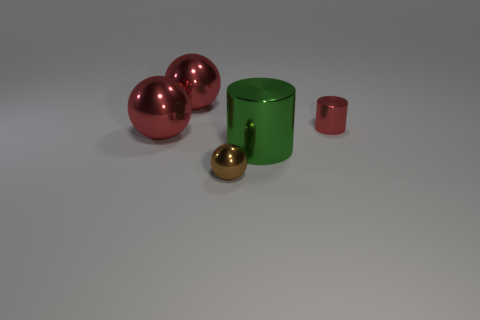There is a red cylinder that is behind the tiny brown metallic ball; is its size the same as the red metallic sphere in front of the small red thing?
Your answer should be compact. No. How many other things are there of the same material as the green cylinder?
Offer a terse response. 4. What number of metallic things are either brown spheres or big green objects?
Make the answer very short. 2. Is the number of cylinders less than the number of brown cylinders?
Offer a very short reply. No. There is a green metal object; does it have the same size as the red object in front of the tiny red object?
Your answer should be compact. Yes. The red metal cylinder is what size?
Your answer should be compact. Small. Is the number of red balls right of the small brown sphere less than the number of big green things?
Your answer should be compact. Yes. Do the green metallic object and the brown metallic object have the same size?
Your response must be concise. No. There is a small cylinder that is the same material as the brown ball; what color is it?
Your response must be concise. Red. Are there fewer large shiny things that are in front of the big green metal thing than small red things that are on the right side of the tiny brown ball?
Your answer should be very brief. Yes. 